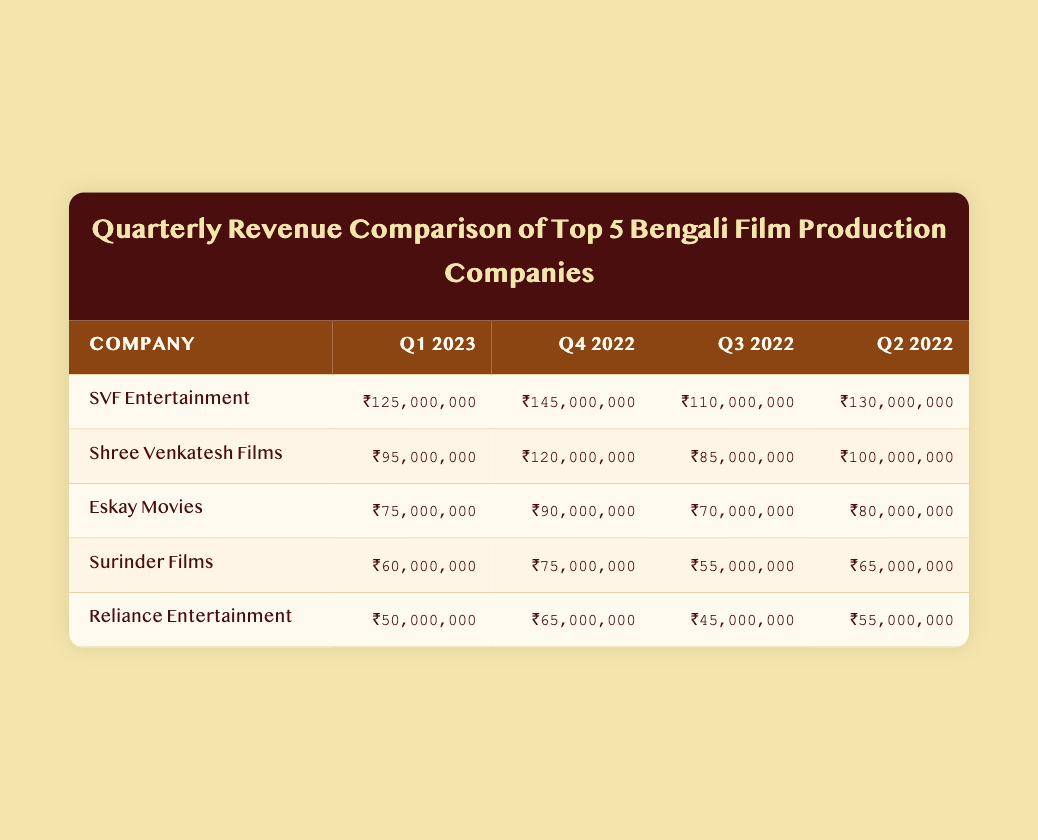What was the revenue for SVF Entertainment in Q1 2023? The table shows that SVF Entertainment earned ₹125,000,000 in Q1 2023.
Answer: ₹125,000,000 Which company had the highest revenue in Q4 2022? According to the table, SVF Entertainment had the highest revenue in Q4 2022 at ₹145,000,000.
Answer: SVF Entertainment What is the total revenue of Eskay Movies across all quarters listed? Eskay Movies' revenues are ₹75,000,000 (Q1 2023) + ₹90,000,000 (Q4 2022) + ₹70,000,000 (Q3 2022) + ₹80,000,000 (Q2 2022), totaling ₹315,000,000.
Answer: ₹315,000,000 Did Surinder Films earn more in Q3 2022 than Reliance Entertainment? In Q3 2022, Surinder Films earned ₹55,000,000 while Reliance Entertainment earned ₹45,000,000, indicating Surinder Films earned more.
Answer: Yes What is the average revenue of Shree Venkatesh Films for the listed quarters? To find the average, sum the revenues of Shree Venkatesh Films: ₹95,000,000 + ₹120,000,000 + ₹85,000,000 + ₹100,000,000 = ₹400,000,000. Divide by 4 (quarters) to get an average of ₹100,000,000.
Answer: ₹100,000,000 Which company had the lowest revenue and in which quarter did it occur? The lowest revenue recorded is ₹50,000,000 by Reliance Entertainment in Q1 2023.
Answer: Reliance Entertainment, Q1 2023 How does the revenue of SVF Entertainment in Q1 2023 compare to its revenue in Q4 2022? SVF Entertainment's revenue decreased from ₹145,000,000 in Q4 2022 to ₹125,000,000 in Q1 2023, showing a decline of ₹20,000,000.
Answer: Decreased by ₹20,000,000 Is it true that Eskay Movies had a consistent increase in revenue from Q2 2022 to Q1 2023? Analyzing the quarters: Eskay Movies had ₹80,000,000 in Q2 2022, ₹70,000,000 in Q3 2022, ₹90,000,000 in Q4 2022, and ₹75,000,000 in Q1 2023, thus it showed fluctuations, not a consistent increase.
Answer: No Which company has the second highest revenue in Q1 2023? In Q1 2023, Shree Venkatesh Films had the second highest revenue of ₹95,000,000 after SVF Entertainment's ₹125,000,000.
Answer: Shree Venkatesh Films 